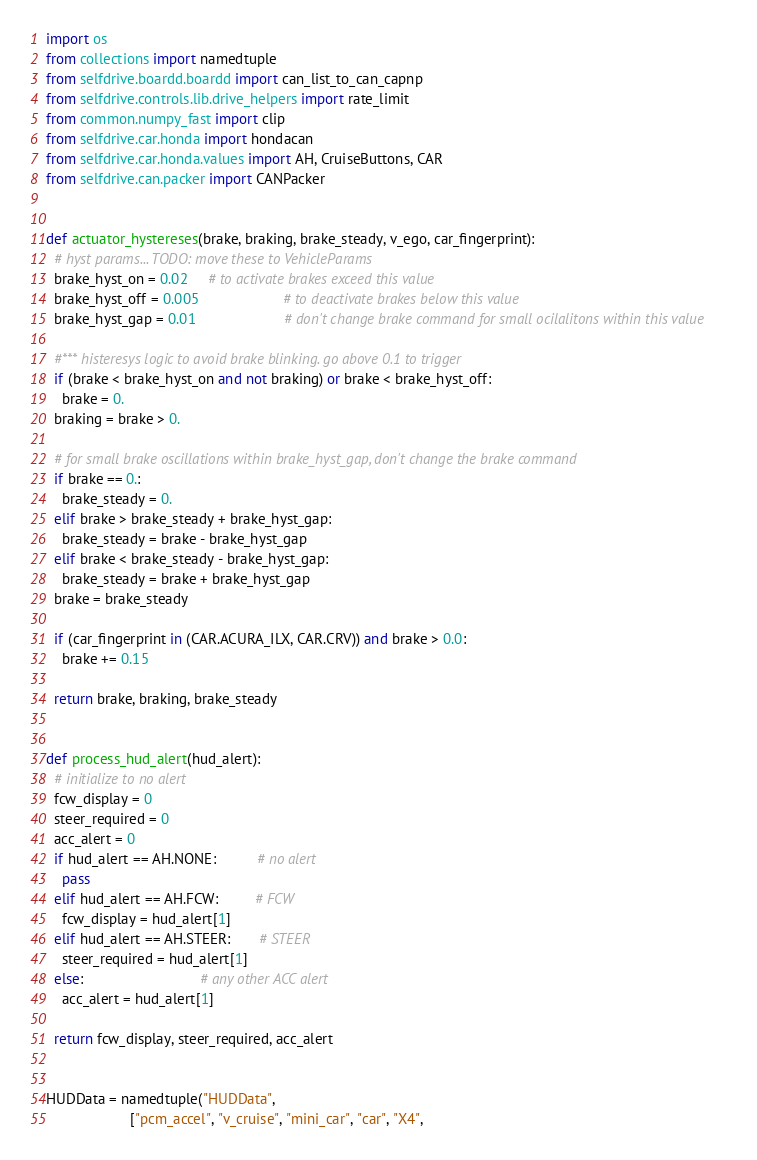Convert code to text. <code><loc_0><loc_0><loc_500><loc_500><_Python_>import os
from collections import namedtuple
from selfdrive.boardd.boardd import can_list_to_can_capnp
from selfdrive.controls.lib.drive_helpers import rate_limit
from common.numpy_fast import clip
from selfdrive.car.honda import hondacan
from selfdrive.car.honda.values import AH, CruiseButtons, CAR
from selfdrive.can.packer import CANPacker


def actuator_hystereses(brake, braking, brake_steady, v_ego, car_fingerprint):
  # hyst params... TODO: move these to VehicleParams
  brake_hyst_on = 0.02     # to activate brakes exceed this value
  brake_hyst_off = 0.005                     # to deactivate brakes below this value
  brake_hyst_gap = 0.01                      # don't change brake command for small ocilalitons within this value

  #*** histeresys logic to avoid brake blinking. go above 0.1 to trigger
  if (brake < brake_hyst_on and not braking) or brake < brake_hyst_off:
    brake = 0.
  braking = brake > 0.

  # for small brake oscillations within brake_hyst_gap, don't change the brake command
  if brake == 0.:
    brake_steady = 0.
  elif brake > brake_steady + brake_hyst_gap:
    brake_steady = brake - brake_hyst_gap
  elif brake < brake_steady - brake_hyst_gap:
    brake_steady = brake + brake_hyst_gap
  brake = brake_steady

  if (car_fingerprint in (CAR.ACURA_ILX, CAR.CRV)) and brake > 0.0:
    brake += 0.15

  return brake, braking, brake_steady


def process_hud_alert(hud_alert):
  # initialize to no alert
  fcw_display = 0
  steer_required = 0
  acc_alert = 0
  if hud_alert == AH.NONE:          # no alert
    pass
  elif hud_alert == AH.FCW:         # FCW
    fcw_display = hud_alert[1]
  elif hud_alert == AH.STEER:       # STEER
    steer_required = hud_alert[1]
  else:                             # any other ACC alert
    acc_alert = hud_alert[1]

  return fcw_display, steer_required, acc_alert


HUDData = namedtuple("HUDData",
                     ["pcm_accel", "v_cruise", "mini_car", "car", "X4",</code> 